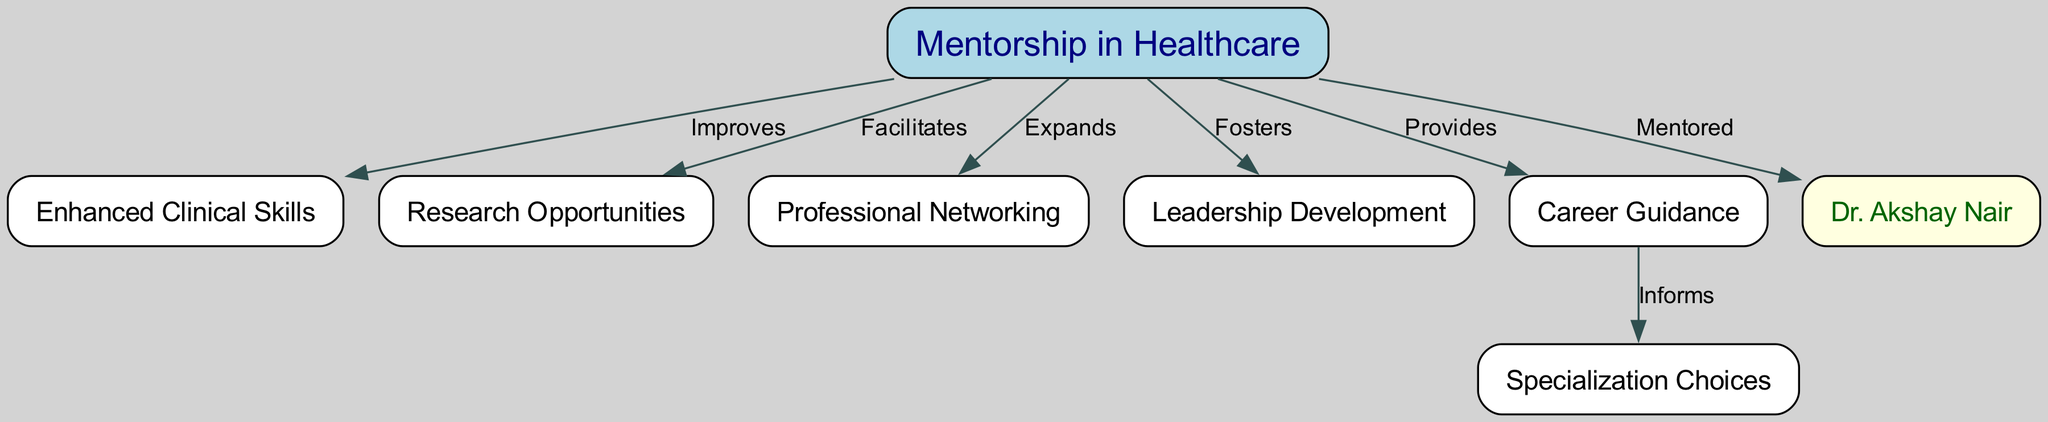What is the central theme of the concept map? The central theme of the concept map is represented by the node labeled "Mentorship in Healthcare," which connects various aspects of how mentorship influences healthcare professionals' careers.
Answer: Mentorship in Healthcare How many nodes are present in the diagram? The diagram contains a total of 8 nodes, which are: Mentorship in Healthcare, Enhanced Clinical Skills, Research Opportunities, Professional Networking, Leadership Development, Career Guidance, Dr. Akshay Nair, and Specialization Choices.
Answer: 8 What relationship does mentorship have with leadership development? Mentorship is linked to leadership development with an "Fosters" relationship, indicating that mentorship plays a role in developing leadership skills among healthcare professionals.
Answer: Fosters Which node is directly connected to "Career Guidance"? The node directly connected to "Career Guidance" in the diagram is "Specialization Choices," showing that career guidance influences the choices a professional makes regarding their specialization.
Answer: Specialization Choices What type of opportunities does mentorship facilitate in healthcare? Mentorship facilitates "Research Opportunities," as indicated by the relationship outlined in the diagram, highlighting how mentorship can lead to increased chances for research involvement.
Answer: Research Opportunities Who is represented as mentored in the diagram? The diagram includes "Dr. Akshay Nair" as the individual who has been mentored, showcasing an example of a mentorship relationship within the healthcare context.
Answer: Dr. Akshay Nair How does mentorship expand professional connections? The concept map shows that mentorship "Expands" Professional Networking, indicating that mentorship can help individuals connect with more professionals in their field.
Answer: Expands What does mentorship provide for career development? Mentorship provides "Career Guidance," which suggests that mentorship is not just about skills enhancement but also includes advice and support for career progression.
Answer: Career Guidance How does mentorship impact specialization choices? Mentorship informs specialization choices by providing career guidance. This indicates that, through mentorship, individuals receive insights that help them make informed decisions about their specializations.
Answer: Informs 